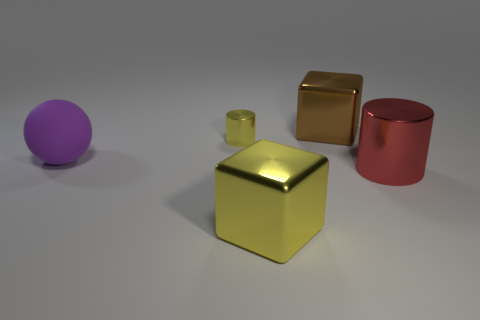Does the tiny thing have the same shape as the shiny thing that is on the right side of the brown metal thing?
Make the answer very short. Yes. There is a shiny object left of the yellow thing in front of the yellow shiny thing that is behind the big cylinder; what is its shape?
Give a very brief answer. Cylinder. How many other things are made of the same material as the small cylinder?
Offer a very short reply. 3. How many objects are either big metallic blocks that are on the left side of the large brown metallic thing or big gray cylinders?
Your answer should be compact. 1. What is the shape of the yellow metallic object left of the big metallic cube in front of the tiny yellow cylinder?
Your response must be concise. Cylinder. There is a big metal thing that is right of the large brown block; is it the same shape as the small metal object?
Provide a succinct answer. Yes. There is a thing that is behind the tiny object; what color is it?
Provide a succinct answer. Brown. How many cylinders are either small purple rubber objects or big red metal things?
Offer a terse response. 1. How big is the shiny cylinder left of the large metallic cube behind the large purple sphere?
Offer a terse response. Small. Do the large rubber ball and the metallic cylinder that is on the left side of the brown shiny cube have the same color?
Offer a very short reply. No. 